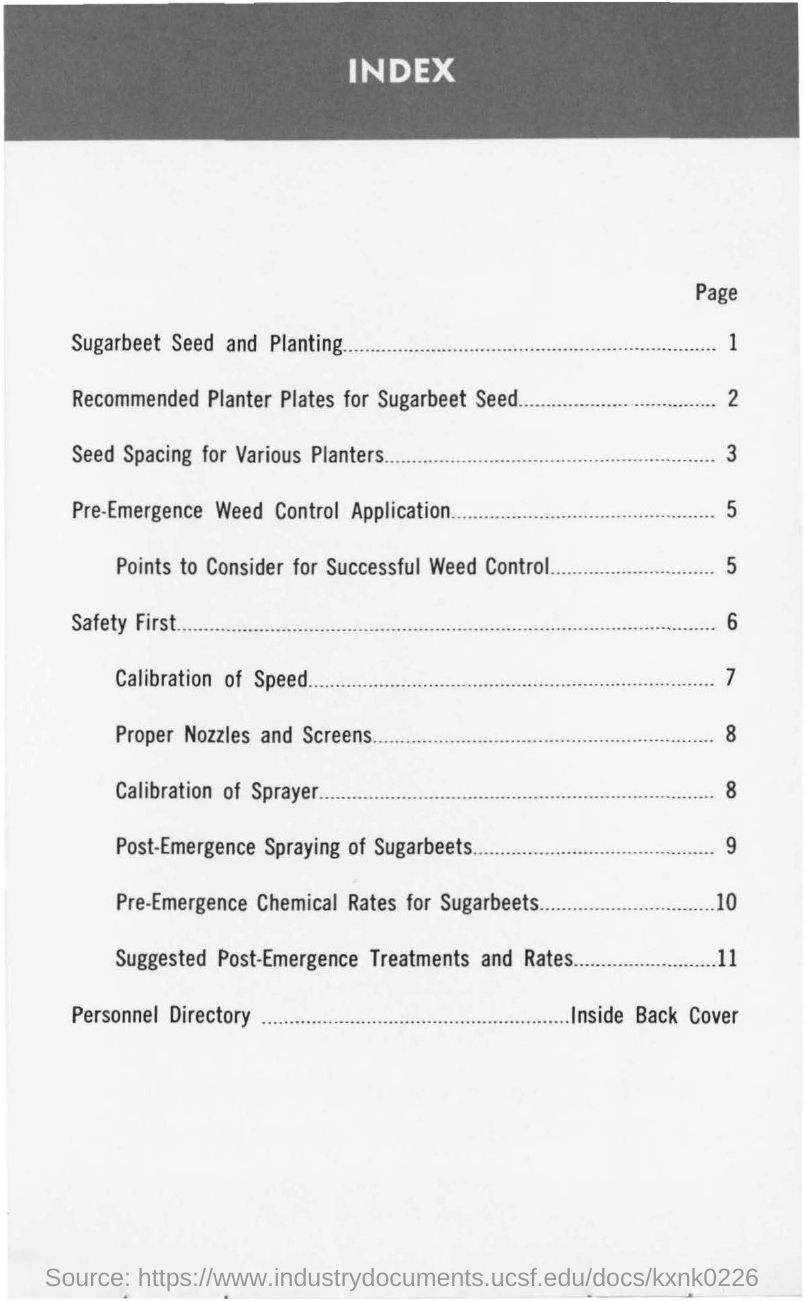Highlight a few significant elements in this photo. The page number of the content "calibration of speed" is 7. I am looking for the page number of the content 'safety first.' The information I have received is that it is on page 6.. The content 'seed spacing for various planters' can be found on page 3. I would like to know the page number of the content titled 'sugarbeet seed and planting'. Could you provide me with the information from 1 to...? 